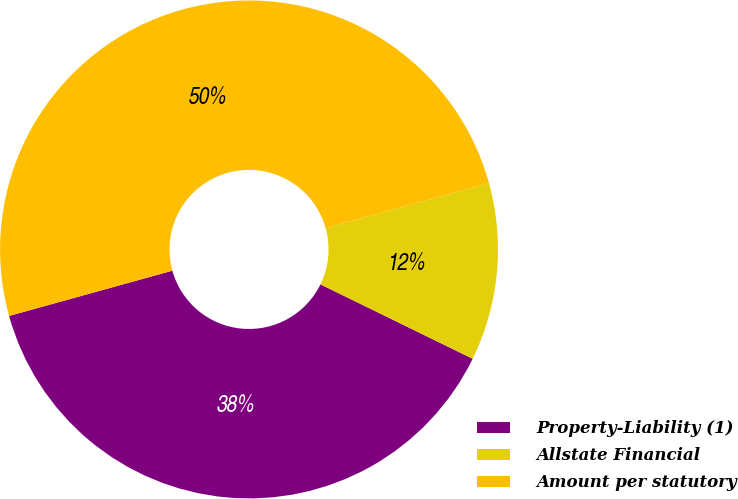Convert chart. <chart><loc_0><loc_0><loc_500><loc_500><pie_chart><fcel>Property-Liability (1)<fcel>Allstate Financial<fcel>Amount per statutory<nl><fcel>38.46%<fcel>11.54%<fcel>50.0%<nl></chart> 